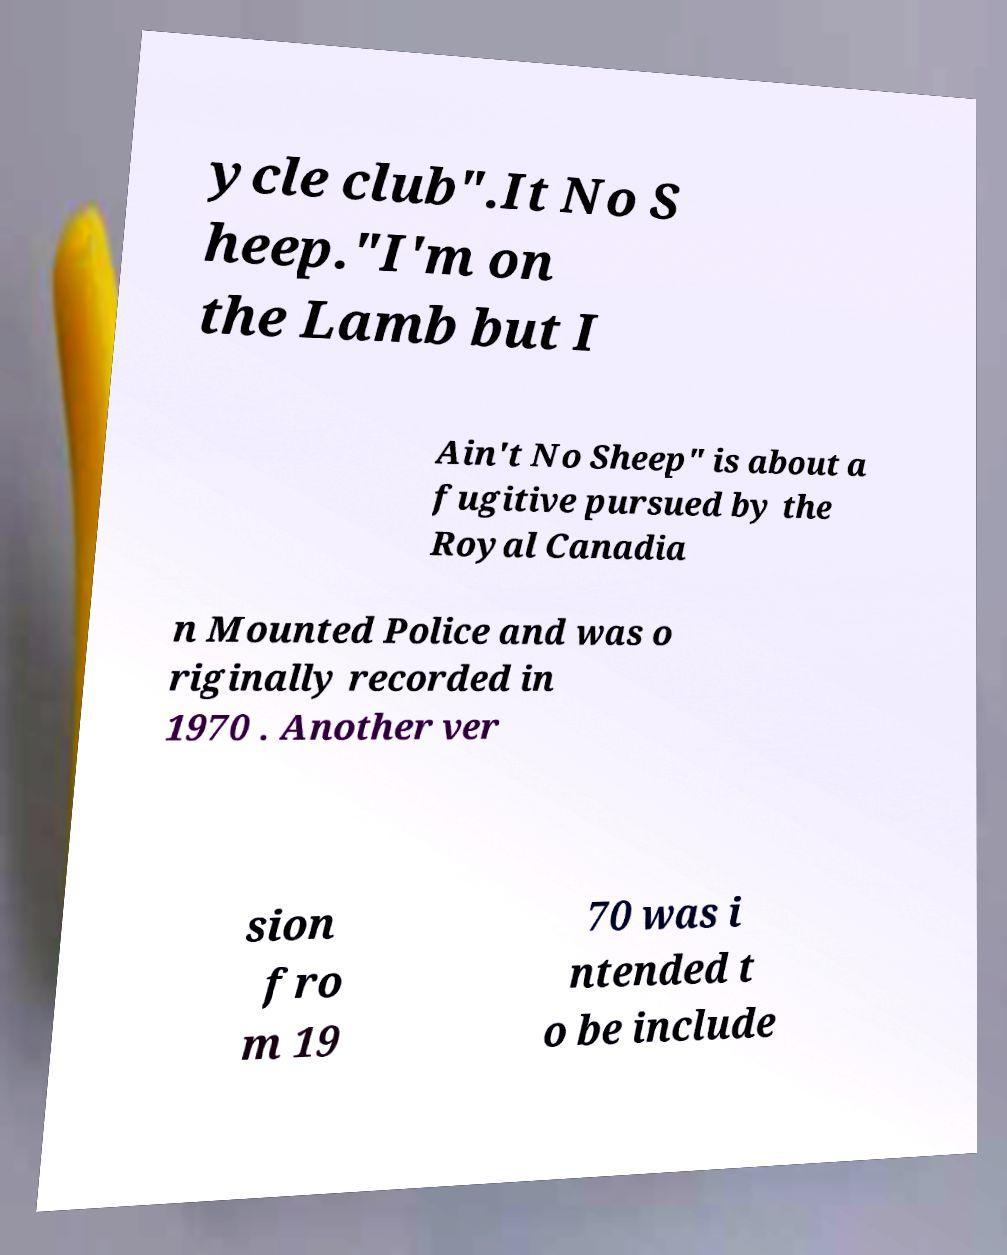What messages or text are displayed in this image? I need them in a readable, typed format. ycle club".It No S heep."I'm on the Lamb but I Ain't No Sheep" is about a fugitive pursued by the Royal Canadia n Mounted Police and was o riginally recorded in 1970 . Another ver sion fro m 19 70 was i ntended t o be include 